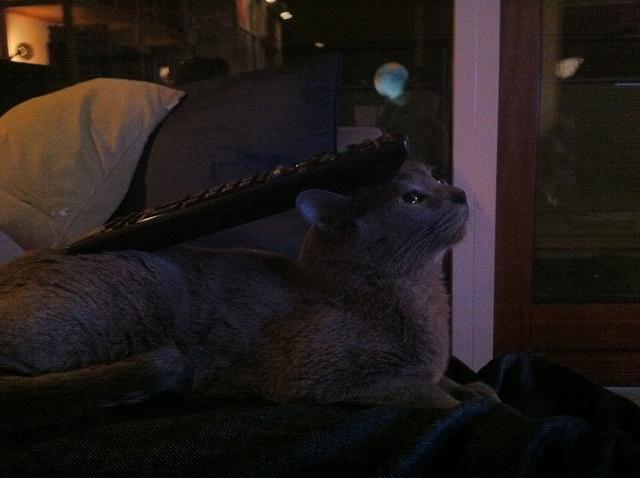What item is the cat balancing on their head?
From the following set of four choices, select the accurate answer to respond to the question.
Options: Puppy, remote control, banana, apple. Remote control. 